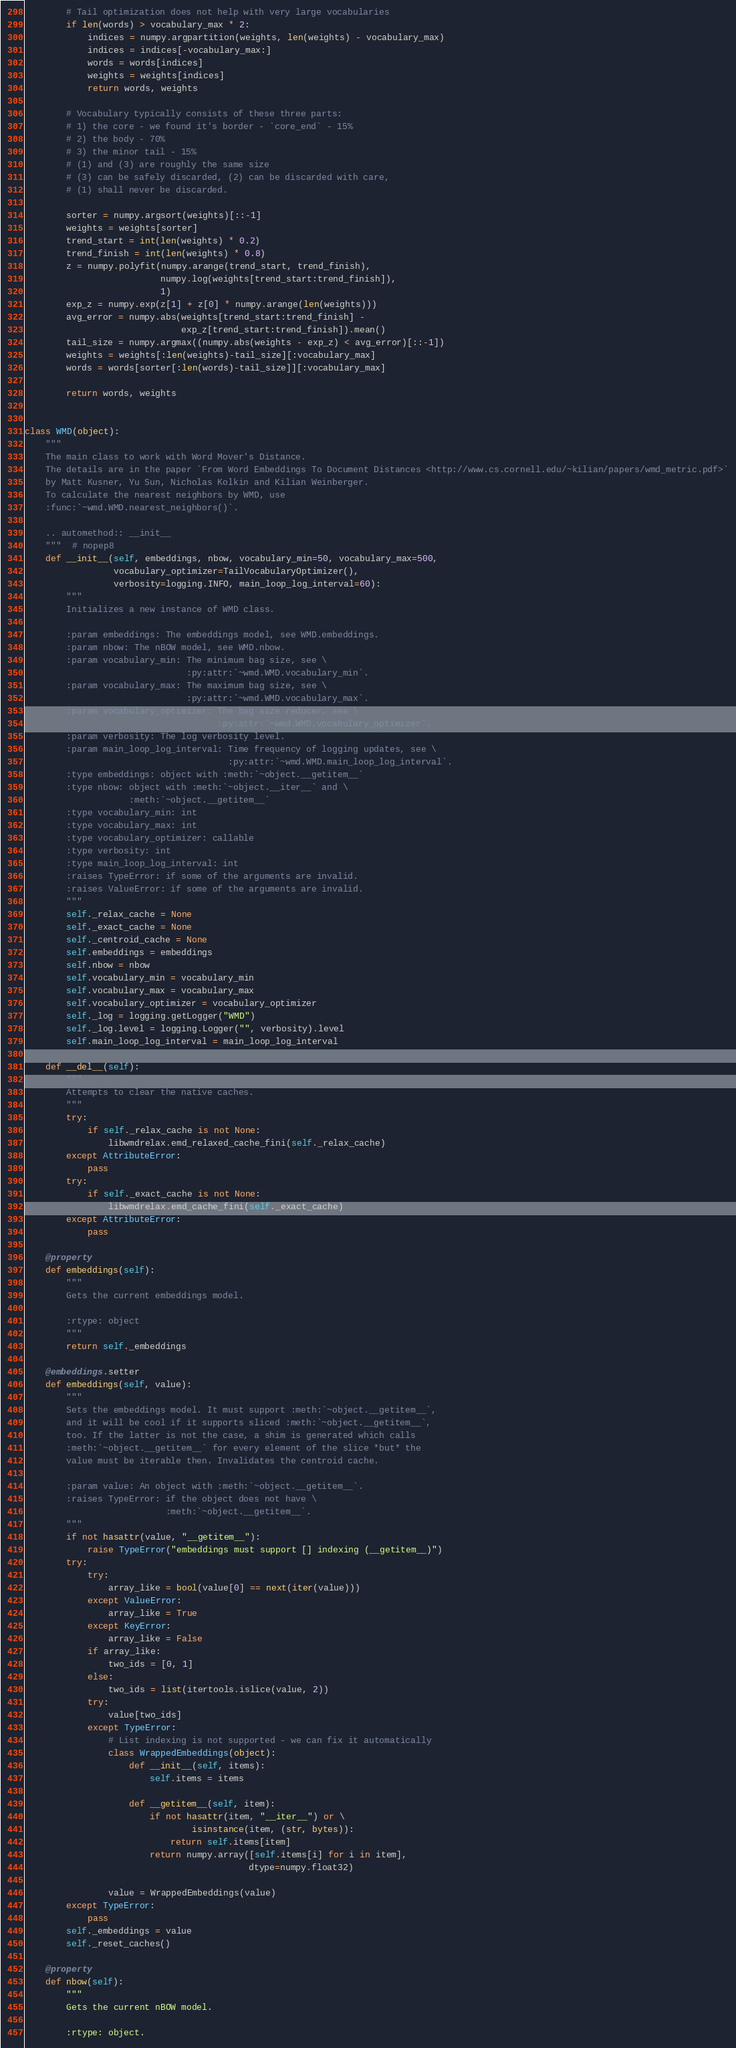Convert code to text. <code><loc_0><loc_0><loc_500><loc_500><_Python_>        # Tail optimization does not help with very large vocabularies
        if len(words) > vocabulary_max * 2:
            indices = numpy.argpartition(weights, len(weights) - vocabulary_max)
            indices = indices[-vocabulary_max:]
            words = words[indices]
            weights = weights[indices]
            return words, weights

        # Vocabulary typically consists of these three parts:
        # 1) the core - we found it's border - `core_end` - 15%
        # 2) the body - 70%
        # 3) the minor tail - 15%
        # (1) and (3) are roughly the same size
        # (3) can be safely discarded, (2) can be discarded with care,
        # (1) shall never be discarded.

        sorter = numpy.argsort(weights)[::-1]
        weights = weights[sorter]
        trend_start = int(len(weights) * 0.2)
        trend_finish = int(len(weights) * 0.8)
        z = numpy.polyfit(numpy.arange(trend_start, trend_finish),
                          numpy.log(weights[trend_start:trend_finish]),
                          1)
        exp_z = numpy.exp(z[1] + z[0] * numpy.arange(len(weights)))
        avg_error = numpy.abs(weights[trend_start:trend_finish] -
                              exp_z[trend_start:trend_finish]).mean()
        tail_size = numpy.argmax((numpy.abs(weights - exp_z) < avg_error)[::-1])
        weights = weights[:len(weights)-tail_size][:vocabulary_max]
        words = words[sorter[:len(words)-tail_size]][:vocabulary_max]

        return words, weights


class WMD(object):
    """
    The main class to work with Word Mover's Distance.
    The details are in the paper `From Word Embeddings To Document Distances <http://www.cs.cornell.edu/~kilian/papers/wmd_metric.pdf>`
    by Matt Kusner, Yu Sun, Nicholas Kolkin and Kilian Weinberger.
    To calculate the nearest neighbors by WMD, use
    :func:`~wmd.WMD.nearest_neighbors()`.

    .. automethod:: __init__
    """  # nopep8
    def __init__(self, embeddings, nbow, vocabulary_min=50, vocabulary_max=500,
                 vocabulary_optimizer=TailVocabularyOptimizer(),
                 verbosity=logging.INFO, main_loop_log_interval=60):
        """
        Initializes a new instance of WMD class.

        :param embeddings: The embeddings model, see WMD.embeddings.
        :param nbow: The nBOW model, see WMD.nbow.
        :param vocabulary_min: The minimum bag size, see \
                               :py:attr:`~wmd.WMD.vocabulary_min`.
        :param vocabulary_max: The maximum bag size, see \
                               :py:attr:`~wmd.WMD.vocabulary_max`.
        :param vocabulary_optimizer: The bag size reducer, see \
                                     :py:attr:`~wmd.WMD.vocabulary_optimizer`.
        :param verbosity: The log verbosity level.
        :param main_loop_log_interval: Time frequency of logging updates, see \
                                       :py:attr:`~wmd.WMD.main_loop_log_interval`.
        :type embeddings: object with :meth:`~object.__getitem__`
        :type nbow: object with :meth:`~object.__iter__` and \
                    :meth:`~object.__getitem__`
        :type vocabulary_min: int
        :type vocabulary_max: int
        :type vocabulary_optimizer: callable
        :type verbosity: int
        :type main_loop_log_interval: int
        :raises TypeError: if some of the arguments are invalid.
        :raises ValueError: if some of the arguments are invalid.
        """
        self._relax_cache = None
        self._exact_cache = None
        self._centroid_cache = None
        self.embeddings = embeddings
        self.nbow = nbow
        self.vocabulary_min = vocabulary_min
        self.vocabulary_max = vocabulary_max
        self.vocabulary_optimizer = vocabulary_optimizer
        self._log = logging.getLogger("WMD")
        self._log.level = logging.Logger("", verbosity).level
        self.main_loop_log_interval = main_loop_log_interval

    def __del__(self):
        """
        Attempts to clear the native caches.
        """
        try:
            if self._relax_cache is not None:
                libwmdrelax.emd_relaxed_cache_fini(self._relax_cache)
        except AttributeError:
            pass
        try:
            if self._exact_cache is not None:
                libwmdrelax.emd_cache_fini(self._exact_cache)
        except AttributeError:
            pass

    @property
    def embeddings(self):
        """
        Gets the current embeddings model.

        :rtype: object
        """
        return self._embeddings

    @embeddings.setter
    def embeddings(self, value):
        """
        Sets the embeddings model. It must support :meth:`~object.__getitem__`,
        and it will be cool if it supports sliced :meth:`~object.__getitem__`,
        too. If the latter is not the case, a shim is generated which calls
        :meth:`~object.__getitem__` for every element of the slice *but* the
        value must be iterable then. Invalidates the centroid cache.

        :param value: An object with :meth:`~object.__getitem__`.
        :raises TypeError: if the object does not have \
                           :meth:`~object.__getitem__`.
        """
        if not hasattr(value, "__getitem__"):
            raise TypeError("embeddings must support [] indexing (__getitem__)")
        try:
            try:
                array_like = bool(value[0] == next(iter(value)))
            except ValueError:
                array_like = True
            except KeyError:
                array_like = False
            if array_like:
                two_ids = [0, 1]
            else:
                two_ids = list(itertools.islice(value, 2))
            try:
                value[two_ids]
            except TypeError:
                # List indexing is not supported - we can fix it automatically
                class WrappedEmbeddings(object):
                    def __init__(self, items):
                        self.items = items

                    def __getitem__(self, item):
                        if not hasattr(item, "__iter__") or \
                                isinstance(item, (str, bytes)):
                            return self.items[item]
                        return numpy.array([self.items[i] for i in item],
                                           dtype=numpy.float32)

                value = WrappedEmbeddings(value)
        except TypeError:
            pass
        self._embeddings = value
        self._reset_caches()

    @property
    def nbow(self):
        """
        Gets the current nBOW model.

        :rtype: object.</code> 